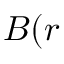Convert formula to latex. <formula><loc_0><loc_0><loc_500><loc_500>B ( r</formula> 